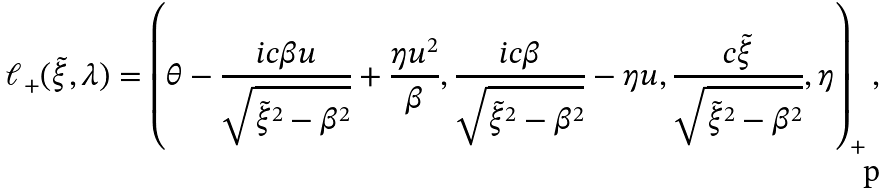<formula> <loc_0><loc_0><loc_500><loc_500>\ell _ { + } ( \tilde { \xi } , \lambda ) = \left ( \theta - \frac { i c \beta u } { \sqrt { \tilde { \xi } ^ { 2 } - \beta ^ { 2 } } } + \frac { \eta u ^ { 2 } } { \beta } , \frac { i c \beta } { \sqrt { \tilde { \xi } ^ { 2 } - \beta ^ { 2 } } } - \eta u , \frac { c \tilde { \xi } } { \sqrt { \tilde { \xi } ^ { 2 } - \beta ^ { 2 } } } , \eta \right ) _ { + } ,</formula> 